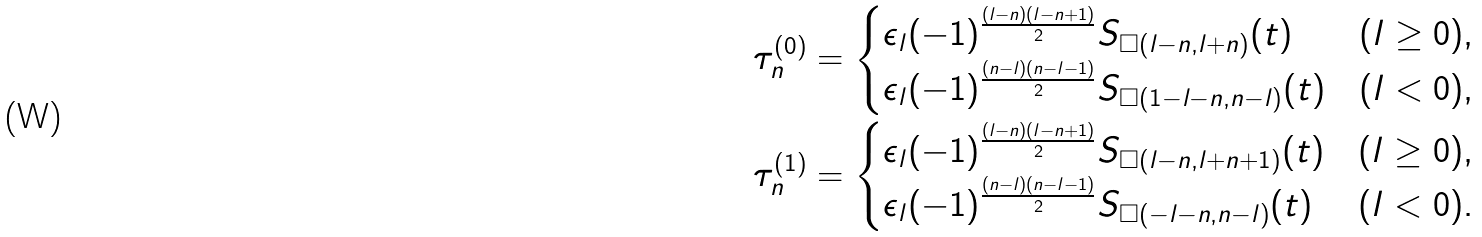<formula> <loc_0><loc_0><loc_500><loc_500>\tau ^ { ( 0 ) } _ { n } & = \begin{cases} \epsilon _ { l } ( - 1 ) ^ { \frac { ( l - n ) ( l - n + 1 ) } { 2 } } S _ { \square ( l - n , l + n ) } ( t ) & ( l \geq 0 ) , \\ \epsilon _ { l } ( - 1 ) ^ { \frac { ( n - l ) ( n - l - 1 ) } { 2 } } S _ { \square ( 1 - l - n , n - l ) } ( t ) & ( l < 0 ) , \end{cases} \\ \tau ^ { ( 1 ) } _ { n } & = \begin{cases} \epsilon _ { l } ( - 1 ) ^ { \frac { ( l - n ) ( l - n + 1 ) } { 2 } } S _ { \square ( l - n , l + n + 1 ) } ( t ) & ( l \geq 0 ) , \\ \epsilon _ { l } ( - 1 ) ^ { \frac { ( n - l ) ( n - l - 1 ) } { 2 } } S _ { \square ( - l - n , n - l ) } ( t ) & ( l < 0 ) . \end{cases}</formula> 